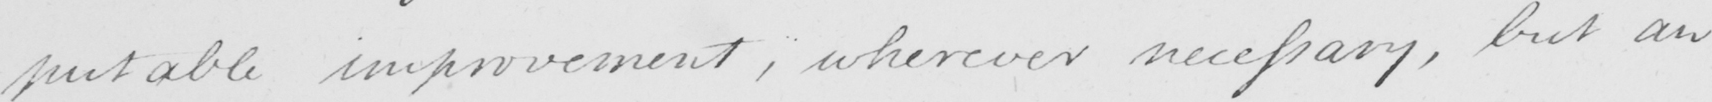What does this handwritten line say? -putable improvement , wherever necessary , but an 